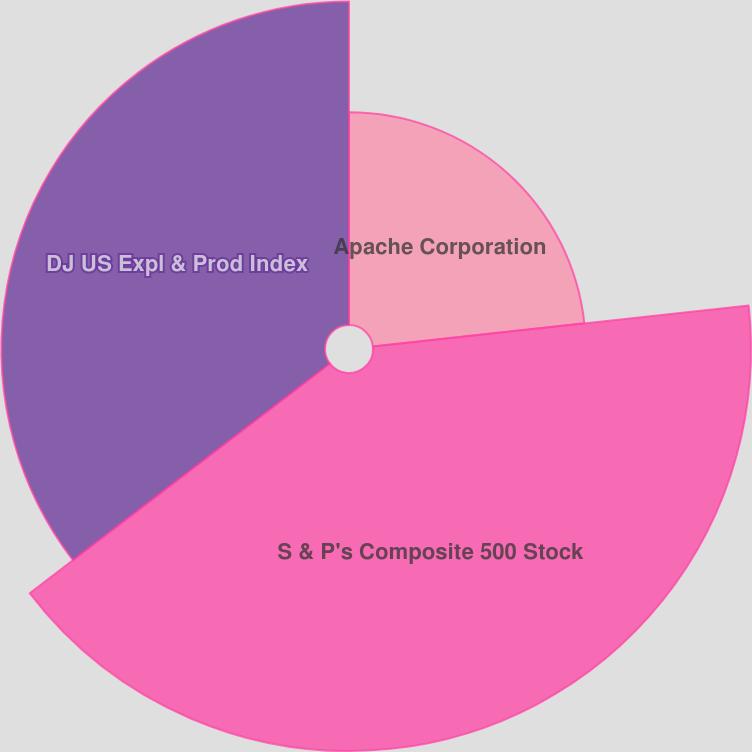Convert chart. <chart><loc_0><loc_0><loc_500><loc_500><pie_chart><fcel>Apache Corporation<fcel>S & P's Composite 500 Stock<fcel>DJ US Expl & Prod Index<nl><fcel>23.27%<fcel>41.34%<fcel>35.39%<nl></chart> 